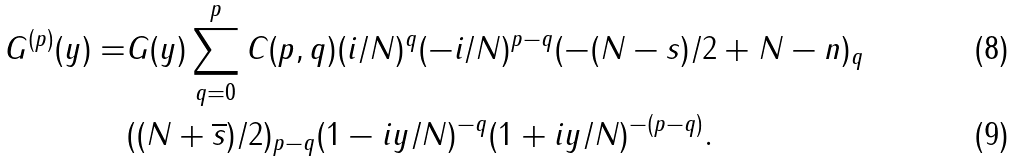<formula> <loc_0><loc_0><loc_500><loc_500>G ^ { ( p ) } ( y ) = & G ( y ) \sum _ { q = 0 } ^ { p } C ( p , q ) ( i / N ) ^ { q } ( - i / N ) ^ { p - q } ( - ( N - s ) / 2 + N - n ) _ { q } \\ & ( ( N + \overline { s } ) / 2 ) _ { p - q } ( 1 - i y / N ) ^ { - q } ( 1 + i y / N ) ^ { - ( p - q ) } .</formula> 